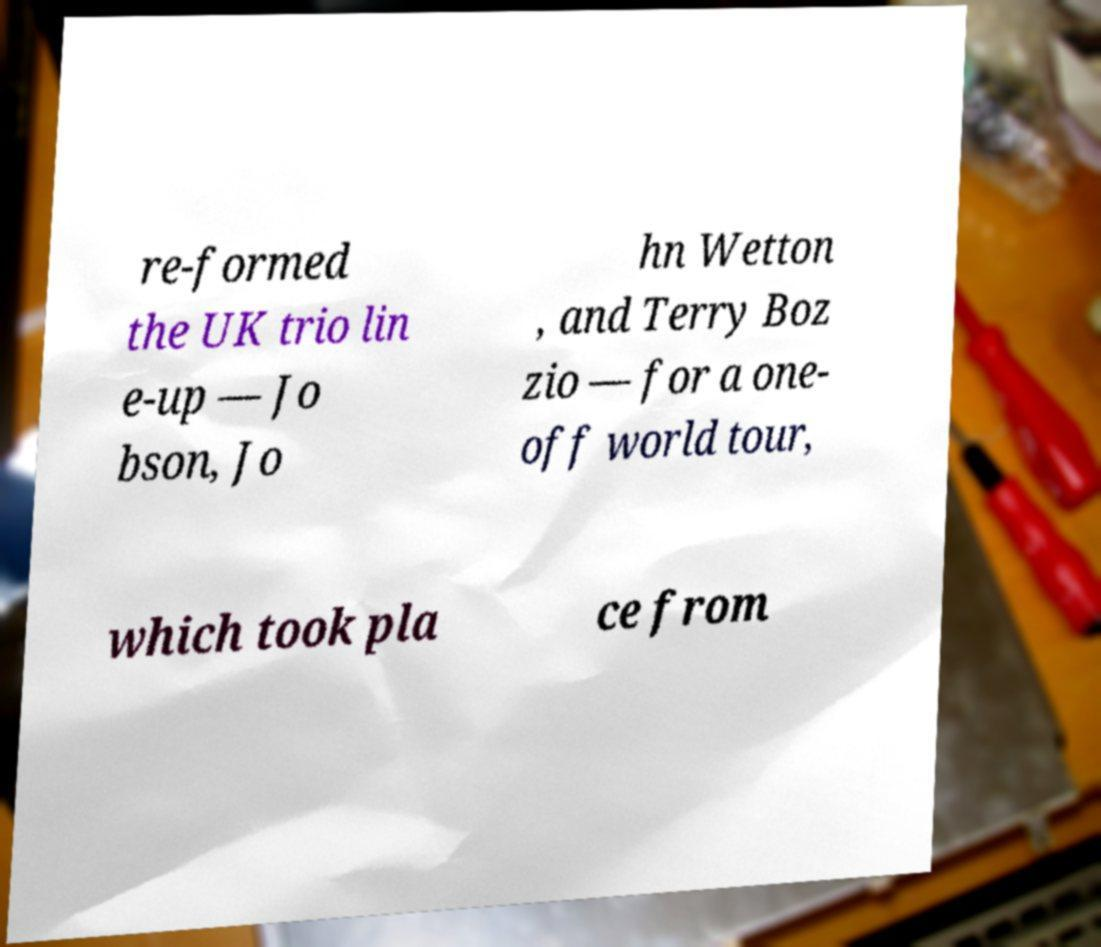Please identify and transcribe the text found in this image. re-formed the UK trio lin e-up — Jo bson, Jo hn Wetton , and Terry Boz zio — for a one- off world tour, which took pla ce from 